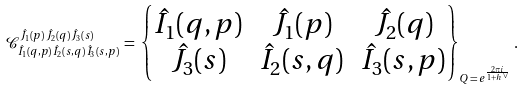<formula> <loc_0><loc_0><loc_500><loc_500>\mathcal { C } ^ { \hat { J } _ { 1 } ( p ) \, \hat { J } _ { 2 } ( q ) \, \hat { J } _ { 3 } ( s ) } _ { \hat { I } _ { 1 } ( q , p ) \, \hat { I } _ { 2 } ( s , q ) \, \hat { I } _ { 3 } ( s , p ) } \, = \, \begin{Bmatrix} \hat { I } _ { 1 } ( q , p ) & \hat { J } _ { 1 } ( p ) & \hat { J } _ { 2 } ( q ) \\ \hat { J } _ { 3 } ( s ) & \hat { I } _ { 2 } ( s , q ) & \hat { I } _ { 3 } ( s , p ) \end{Bmatrix} _ { Q \, = \, e ^ { \frac { 2 \pi i } { 1 + h ^ { \vee } } } } .</formula> 